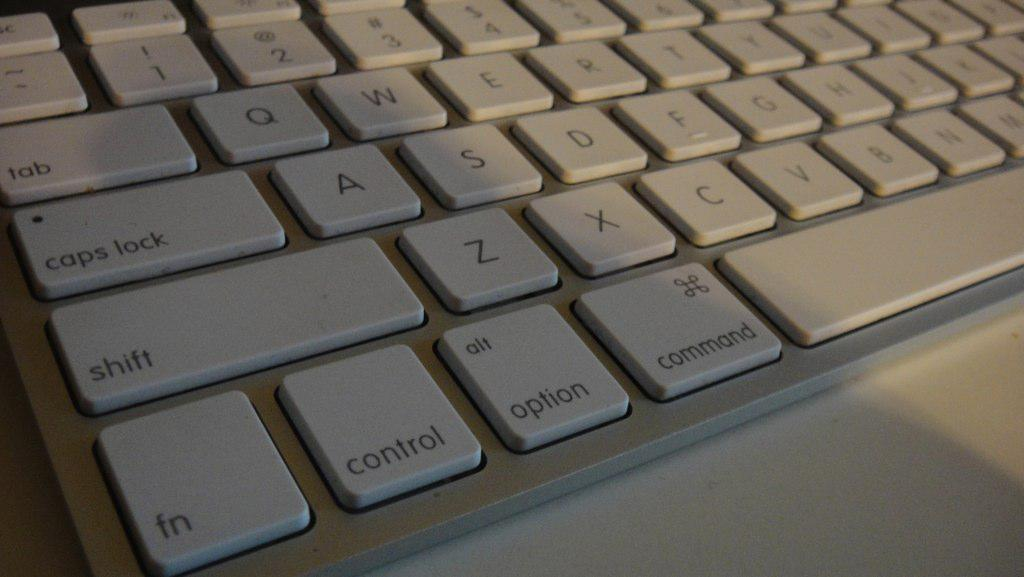What is the main object in the image? There is a keyboard in the image. What is the keyboard placed on? The keyboard is on a white surface. What color is the keyboard? The keyboard is silver in color. What is the name of the toad that is sitting on the keyboard in the image? There is no toad present in the image, so it cannot be determined if a toad has a name. 